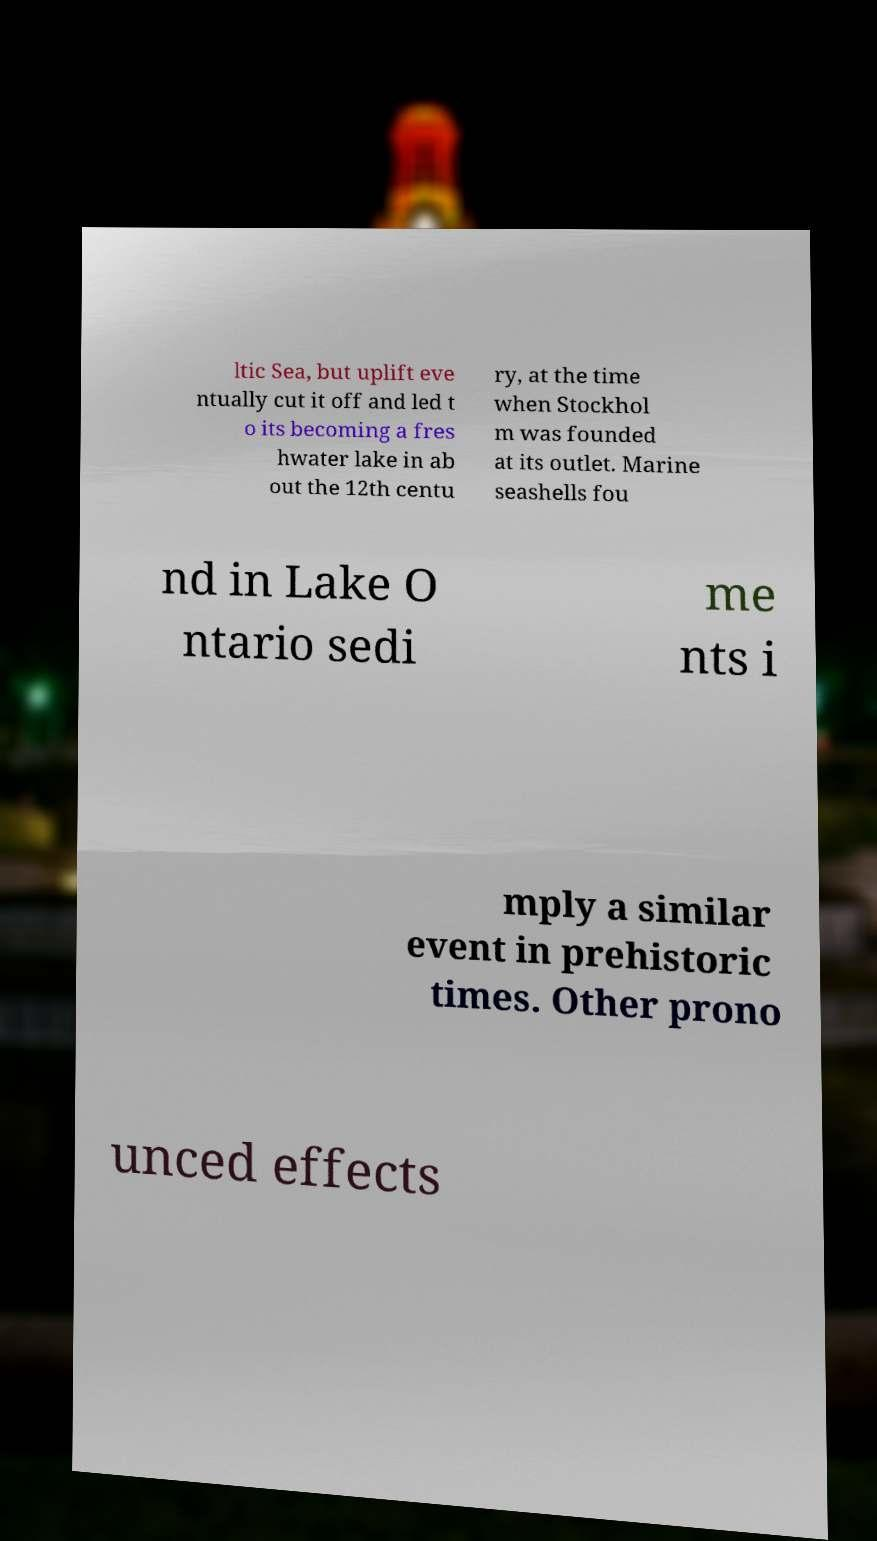What messages or text are displayed in this image? I need them in a readable, typed format. ltic Sea, but uplift eve ntually cut it off and led t o its becoming a fres hwater lake in ab out the 12th centu ry, at the time when Stockhol m was founded at its outlet. Marine seashells fou nd in Lake O ntario sedi me nts i mply a similar event in prehistoric times. Other prono unced effects 